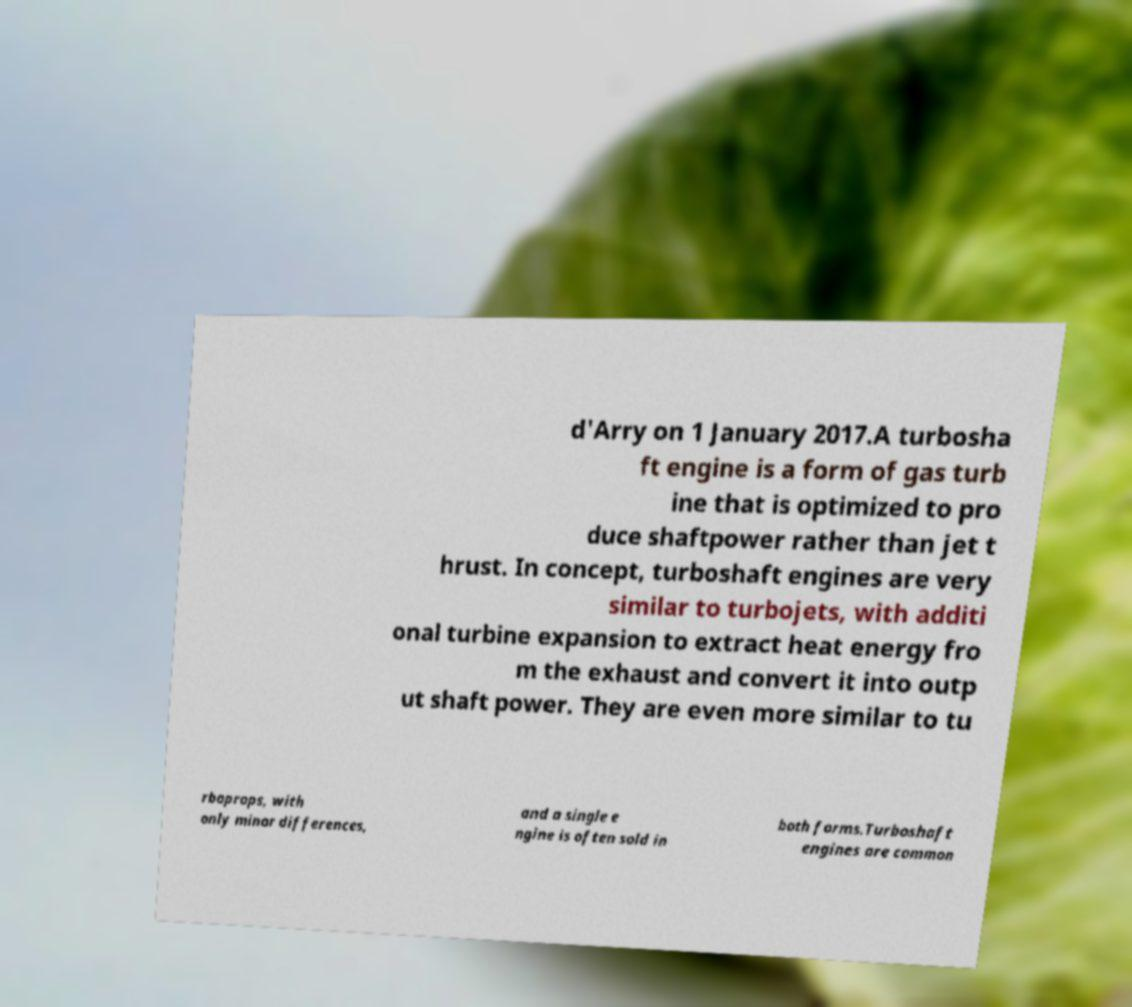Can you read and provide the text displayed in the image?This photo seems to have some interesting text. Can you extract and type it out for me? d'Arry on 1 January 2017.A turbosha ft engine is a form of gas turb ine that is optimized to pro duce shaftpower rather than jet t hrust. In concept, turboshaft engines are very similar to turbojets, with additi onal turbine expansion to extract heat energy fro m the exhaust and convert it into outp ut shaft power. They are even more similar to tu rboprops, with only minor differences, and a single e ngine is often sold in both forms.Turboshaft engines are common 